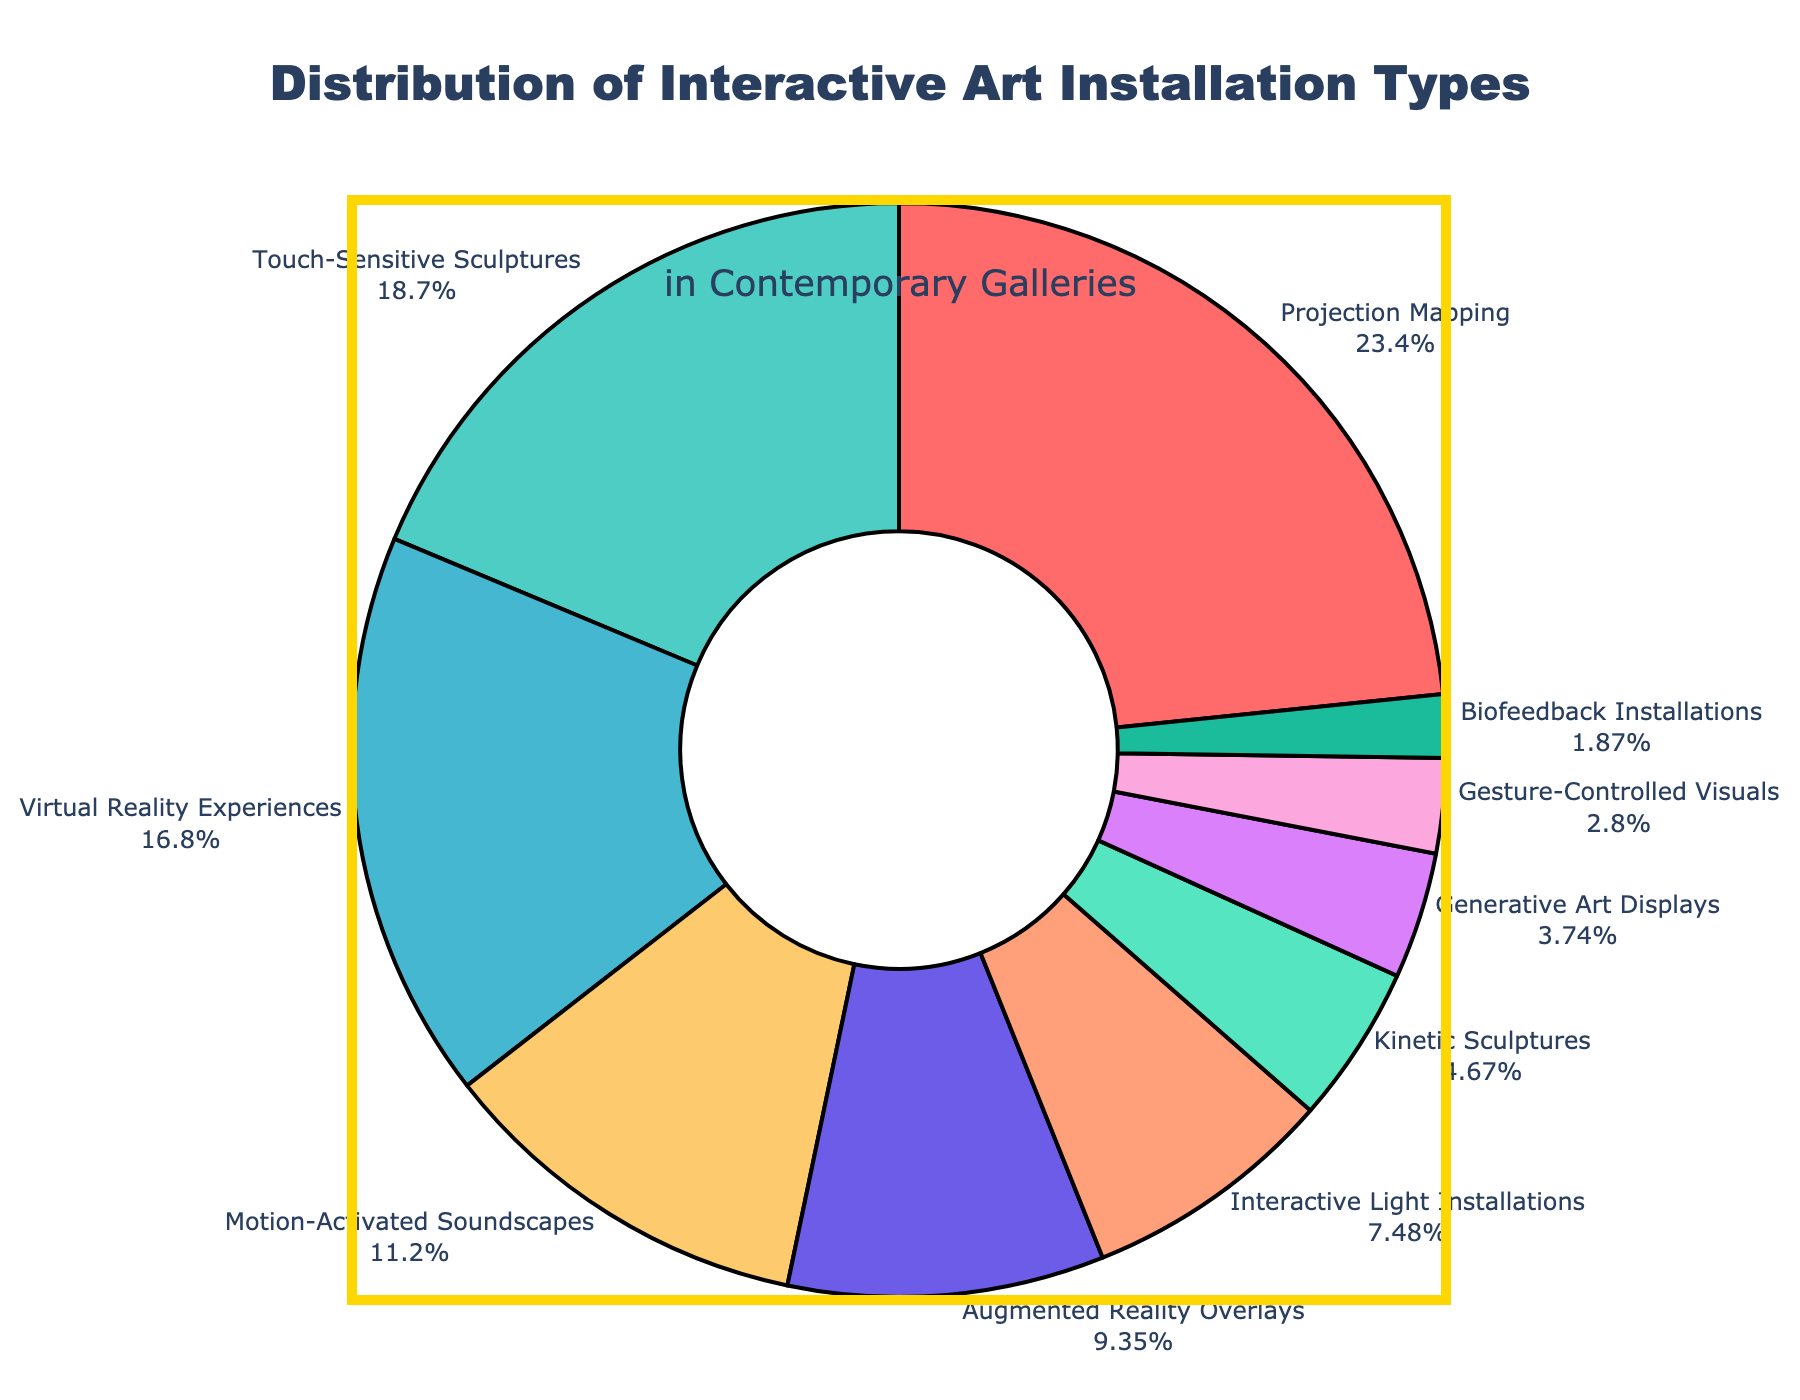What is the most common type of interactive art installation in contemporary galleries? The segment labeled "Projection Mapping" constitutes the largest portion of the pie chart. Therefore, it represents the most common type of interactive art installation.
Answer: Projection Mapping Which two types of installations together make up less than 20% of the total? The segments labeled "Gesture-Controlled Visuals" (3%) and "Biofeedback Installations" (2%) together account for 5%, which is less than 20%.
Answer: Gesture-Controlled Visuals and Biofeedback Installations Are there more Virtual Reality Experiences or Augmented Reality Overlays in the distribution? By comparing the segments, the "Virtual Reality Experiences" segment (18%) is larger than the "Augmented Reality Overlays" segment (10%).
Answer: Virtual Reality Experiences Which type has a smaller percentage, Kinetic Sculptures or Generative Art Displays? Comparing the segments labeled "Kinetic Sculptures" (5%) and "Generative Art Displays" (4%), the latter is smaller.
Answer: Generative Art Displays What's the combined percentage of Projection Mapping and Touch-Sensitive Sculptures? Adding the percentages from the segments for "Projection Mapping" (25%) and "Touch-Sensitive Sculptures" (20%) gives 25% + 20% = 45%.
Answer: 45% What's the difference in percentage between Interactive Light Installations and Motion-Activated Soundscapes? The segment labeled "Interactive Light Installations" is 8%, and the segment for "Motion-Activated Soundscapes" is 12%. The difference is 12% - 8% = 4%.
Answer: 4% Which type of installation is represented by the red color? The segment with red color corresponds to "Projection Mapping" in the pie chart.
Answer: Projection Mapping How many types of installations have a percentage greater than 10%? The segments labeled "Projection Mapping" (25%), "Touch-Sensitive Sculptures" (20%), "Virtual Reality Experiences" (18%), and "Motion-Activated Soundscapes" (12%) are greater than 10%. There are four such types.
Answer: 4 Between Augmented Reality Overlays and Interactive Light Installations, which has the higher percentage? The segment labeled "Augmented Reality Overlays" is 10%, which is higher compared to "Interactive Light Installations" at 8%.
Answer: Augmented Reality Overlays What is the total percentage of installations categorized under less than 5% each? Adding the percentages from the segments for "Kinetic Sculptures" (5%), "Generative Art Displays" (4%), "Gesture-Controlled Visuals" (3%), and "Biofeedback Installations" (2%), we get 5% + 4% + 3% + 2% = 14%.
Answer: 14% 